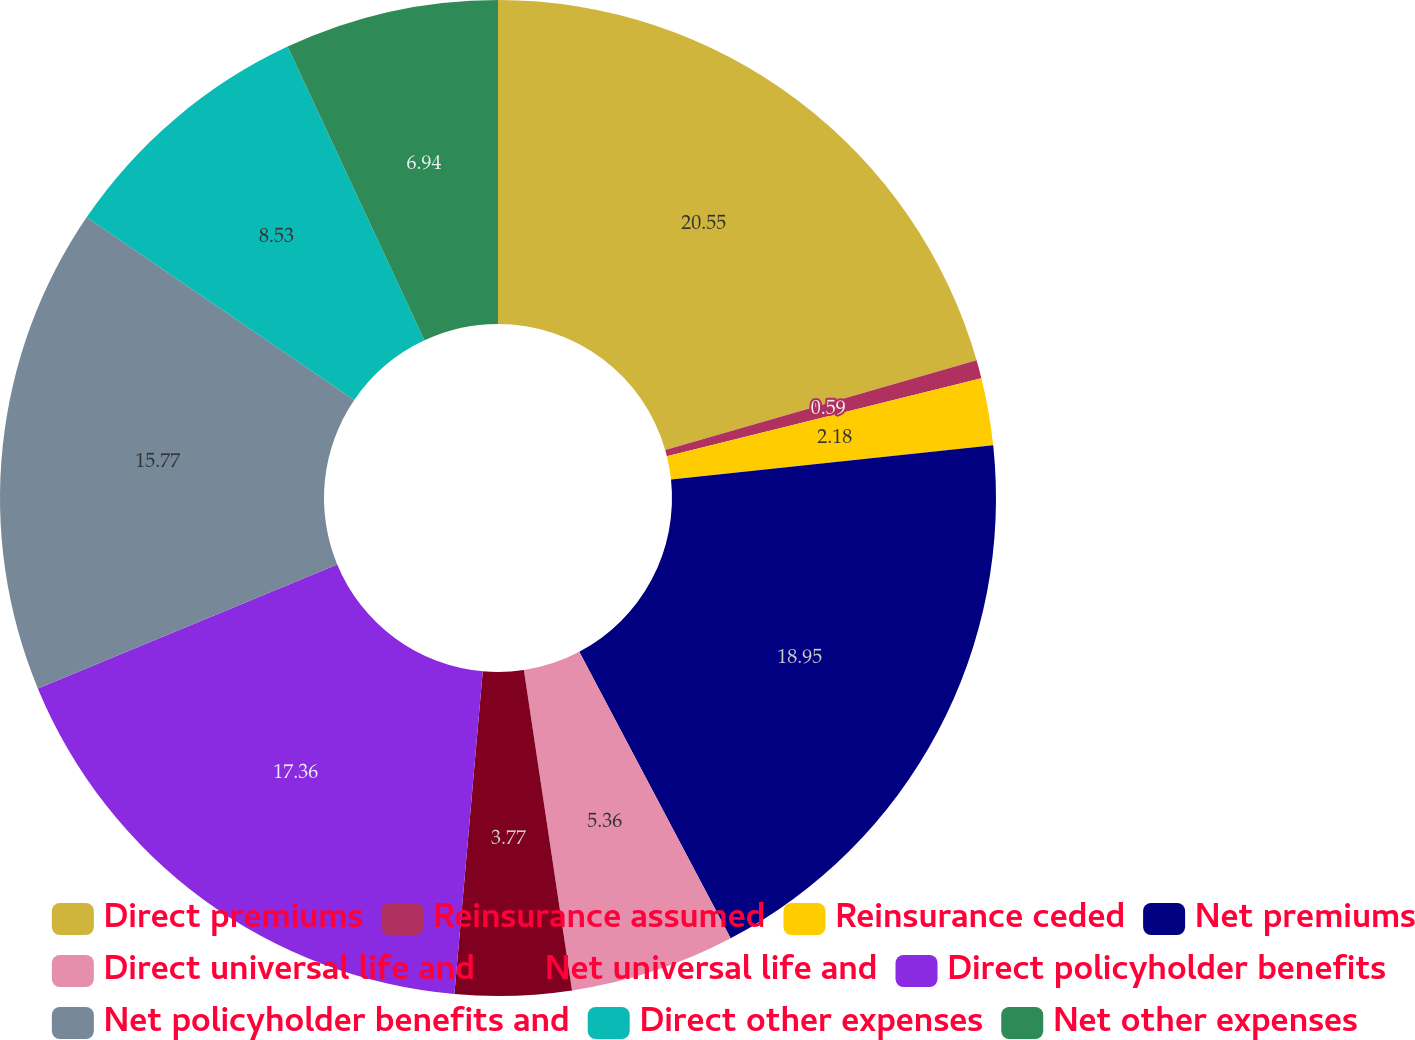Convert chart. <chart><loc_0><loc_0><loc_500><loc_500><pie_chart><fcel>Direct premiums<fcel>Reinsurance assumed<fcel>Reinsurance ceded<fcel>Net premiums<fcel>Direct universal life and<fcel>Net universal life and<fcel>Direct policyholder benefits<fcel>Net policyholder benefits and<fcel>Direct other expenses<fcel>Net other expenses<nl><fcel>20.54%<fcel>0.59%<fcel>2.18%<fcel>18.95%<fcel>5.36%<fcel>3.77%<fcel>17.36%<fcel>15.77%<fcel>8.53%<fcel>6.94%<nl></chart> 